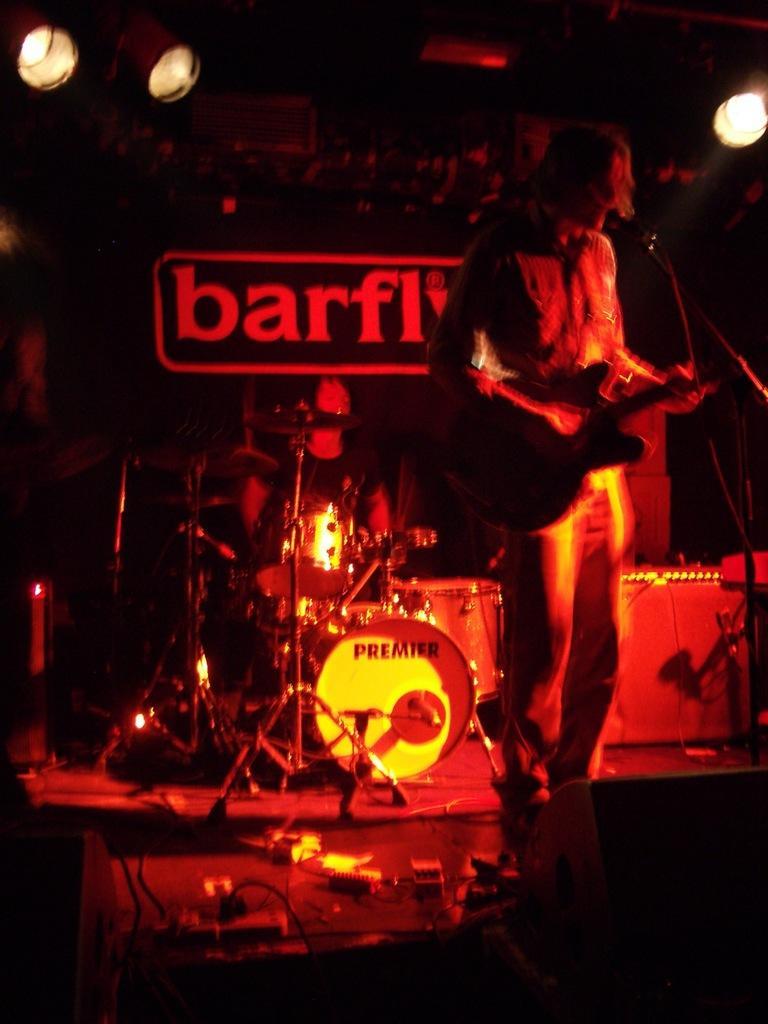In one or two sentences, can you explain what this image depicts? In this picture we can see a person playing a guitar. There are few drums and other musical instruments. We can see wires and switchboards on the stage. Some lights are visible in the background. 